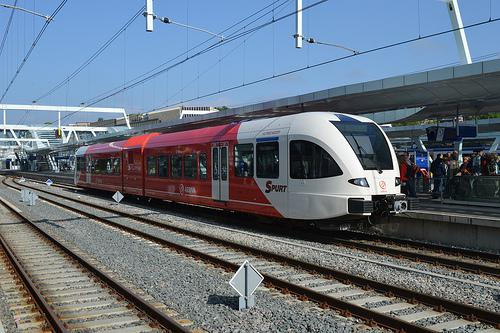Question: where is this shot?
Choices:
A. Outside.
B. Inside.
C. Platform.
D. House.
Answer with the letter. Answer: C Question: what does the train carry?
Choices:
A. Cargo.
B. Wood.
C. Lumber.
D. People.
Answer with the letter. Answer: D Question: how many colors are the train?
Choices:
A. 1.
B. 2.
C. 3.
D. 4.
Answer with the letter. Answer: B 